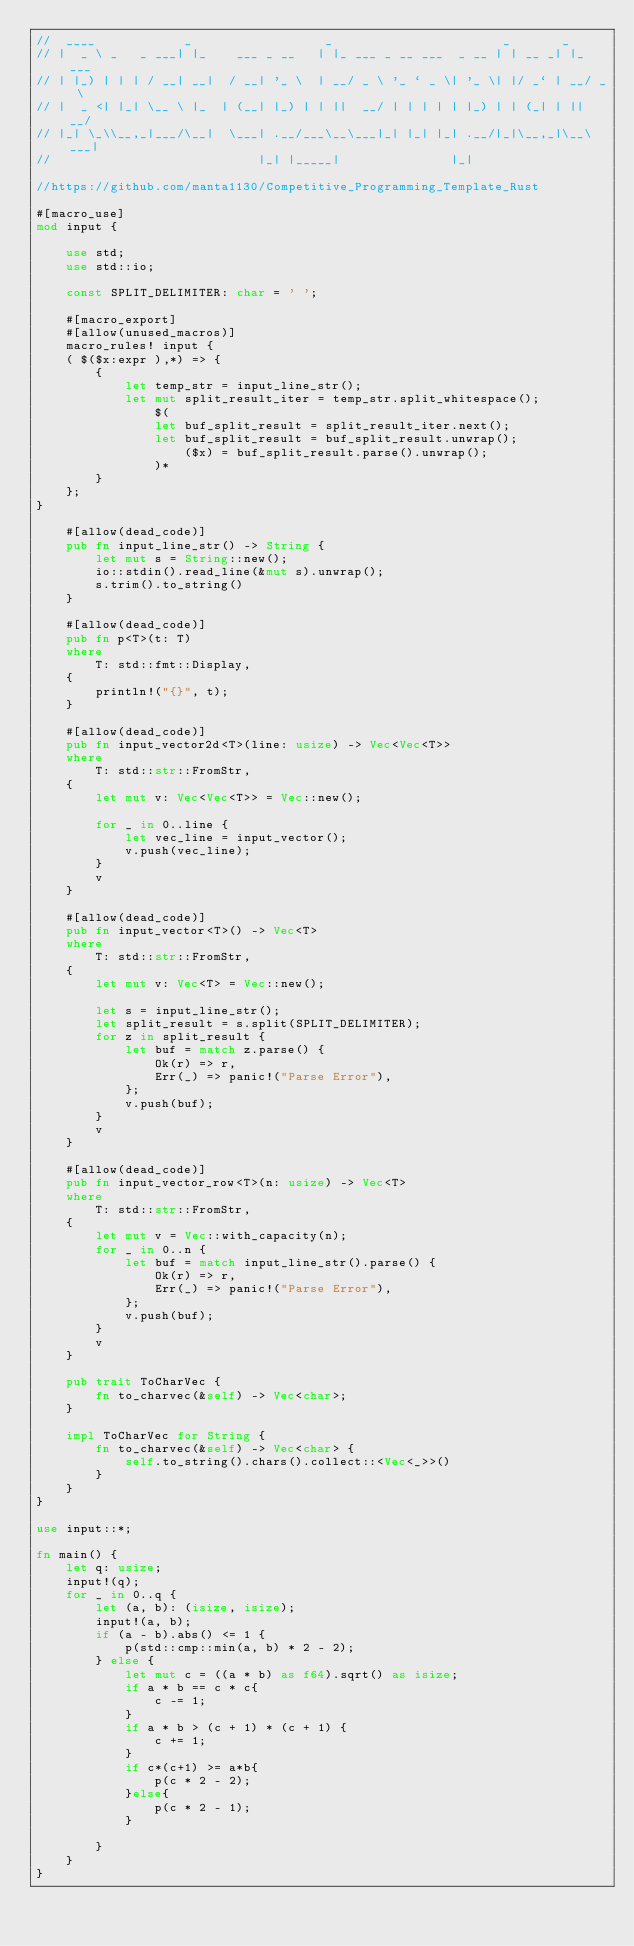<code> <loc_0><loc_0><loc_500><loc_500><_Rust_>//  ____            _                  _                       _       _
// |  _ \ _   _ ___| |_    ___ _ __   | |_ ___ _ __ ___  _ __ | | __ _| |_ ___
// | |_) | | | / __| __|  / __| '_ \  | __/ _ \ '_ ` _ \| '_ \| |/ _` | __/ _ \
// |  _ <| |_| \__ \ |_  | (__| |_) | | ||  __/ | | | | | |_) | | (_| | ||  __/
// |_| \_\\__,_|___/\__|  \___| .__/___\__\___|_| |_| |_| .__/|_|\__,_|\__\___|
//                            |_| |_____|               |_|

//https://github.com/manta1130/Competitive_Programming_Template_Rust

#[macro_use]
mod input {

    use std;
    use std::io;

    const SPLIT_DELIMITER: char = ' ';

    #[macro_export]
    #[allow(unused_macros)]
    macro_rules! input {
    ( $($x:expr ),*) => {
        {
            let temp_str = input_line_str();
            let mut split_result_iter = temp_str.split_whitespace();
                $(
                let buf_split_result = split_result_iter.next();
                let buf_split_result = buf_split_result.unwrap();
                    ($x) = buf_split_result.parse().unwrap();
                )*
        }
    };
}

    #[allow(dead_code)]
    pub fn input_line_str() -> String {
        let mut s = String::new();
        io::stdin().read_line(&mut s).unwrap();
        s.trim().to_string()
    }

    #[allow(dead_code)]
    pub fn p<T>(t: T)
    where
        T: std::fmt::Display,
    {
        println!("{}", t);
    }

    #[allow(dead_code)]
    pub fn input_vector2d<T>(line: usize) -> Vec<Vec<T>>
    where
        T: std::str::FromStr,
    {
        let mut v: Vec<Vec<T>> = Vec::new();

        for _ in 0..line {
            let vec_line = input_vector();
            v.push(vec_line);
        }
        v
    }

    #[allow(dead_code)]
    pub fn input_vector<T>() -> Vec<T>
    where
        T: std::str::FromStr,
    {
        let mut v: Vec<T> = Vec::new();

        let s = input_line_str();
        let split_result = s.split(SPLIT_DELIMITER);
        for z in split_result {
            let buf = match z.parse() {
                Ok(r) => r,
                Err(_) => panic!("Parse Error"),
            };
            v.push(buf);
        }
        v
    }

    #[allow(dead_code)]
    pub fn input_vector_row<T>(n: usize) -> Vec<T>
    where
        T: std::str::FromStr,
    {
        let mut v = Vec::with_capacity(n);
        for _ in 0..n {
            let buf = match input_line_str().parse() {
                Ok(r) => r,
                Err(_) => panic!("Parse Error"),
            };
            v.push(buf);
        }
        v
    }

    pub trait ToCharVec {
        fn to_charvec(&self) -> Vec<char>;
    }

    impl ToCharVec for String {
        fn to_charvec(&self) -> Vec<char> {
            self.to_string().chars().collect::<Vec<_>>()
        }
    }
}

use input::*;

fn main() {
    let q: usize;
    input!(q);
    for _ in 0..q {
        let (a, b): (isize, isize);
        input!(a, b);
        if (a - b).abs() <= 1 {
            p(std::cmp::min(a, b) * 2 - 2);
        } else {
            let mut c = ((a * b) as f64).sqrt() as isize;
            if a * b == c * c{
                c -= 1;
            }
            if a * b > (c + 1) * (c + 1) {
                c += 1;
            }
            if c*(c+1) >= a*b{
                p(c * 2 - 2);
            }else{
                p(c * 2 - 1);
            }
            
        }
    }
}
</code> 